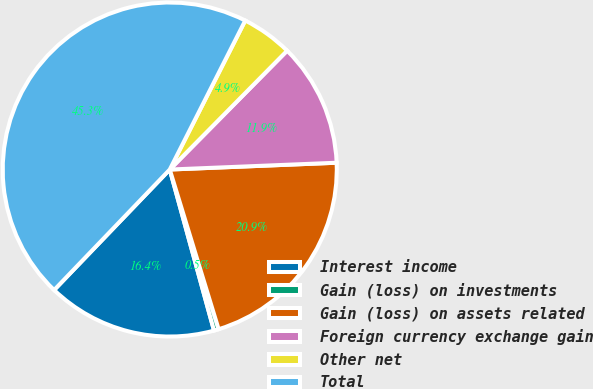<chart> <loc_0><loc_0><loc_500><loc_500><pie_chart><fcel>Interest income<fcel>Gain (loss) on investments<fcel>Gain (loss) on assets related<fcel>Foreign currency exchange gain<fcel>Other net<fcel>Total<nl><fcel>16.44%<fcel>0.46%<fcel>20.92%<fcel>11.95%<fcel>4.94%<fcel>45.29%<nl></chart> 